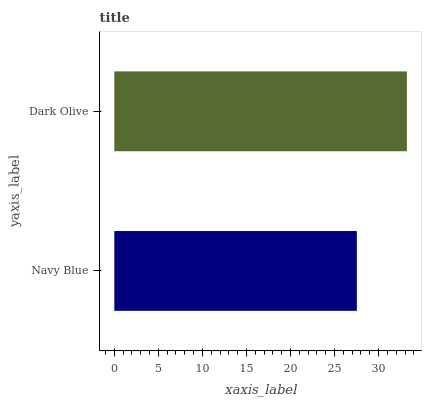Is Navy Blue the minimum?
Answer yes or no. Yes. Is Dark Olive the maximum?
Answer yes or no. Yes. Is Dark Olive the minimum?
Answer yes or no. No. Is Dark Olive greater than Navy Blue?
Answer yes or no. Yes. Is Navy Blue less than Dark Olive?
Answer yes or no. Yes. Is Navy Blue greater than Dark Olive?
Answer yes or no. No. Is Dark Olive less than Navy Blue?
Answer yes or no. No. Is Dark Olive the high median?
Answer yes or no. Yes. Is Navy Blue the low median?
Answer yes or no. Yes. Is Navy Blue the high median?
Answer yes or no. No. Is Dark Olive the low median?
Answer yes or no. No. 